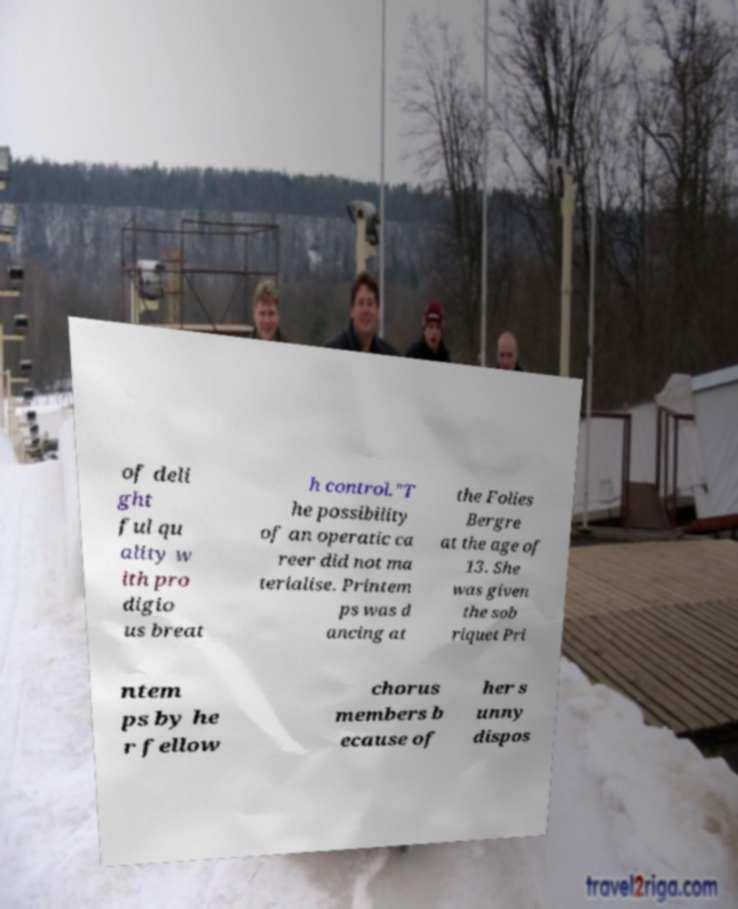Can you read and provide the text displayed in the image?This photo seems to have some interesting text. Can you extract and type it out for me? of deli ght ful qu ality w ith pro digio us breat h control."T he possibility of an operatic ca reer did not ma terialise. Printem ps was d ancing at the Folies Bergre at the age of 13. She was given the sob riquet Pri ntem ps by he r fellow chorus members b ecause of her s unny dispos 